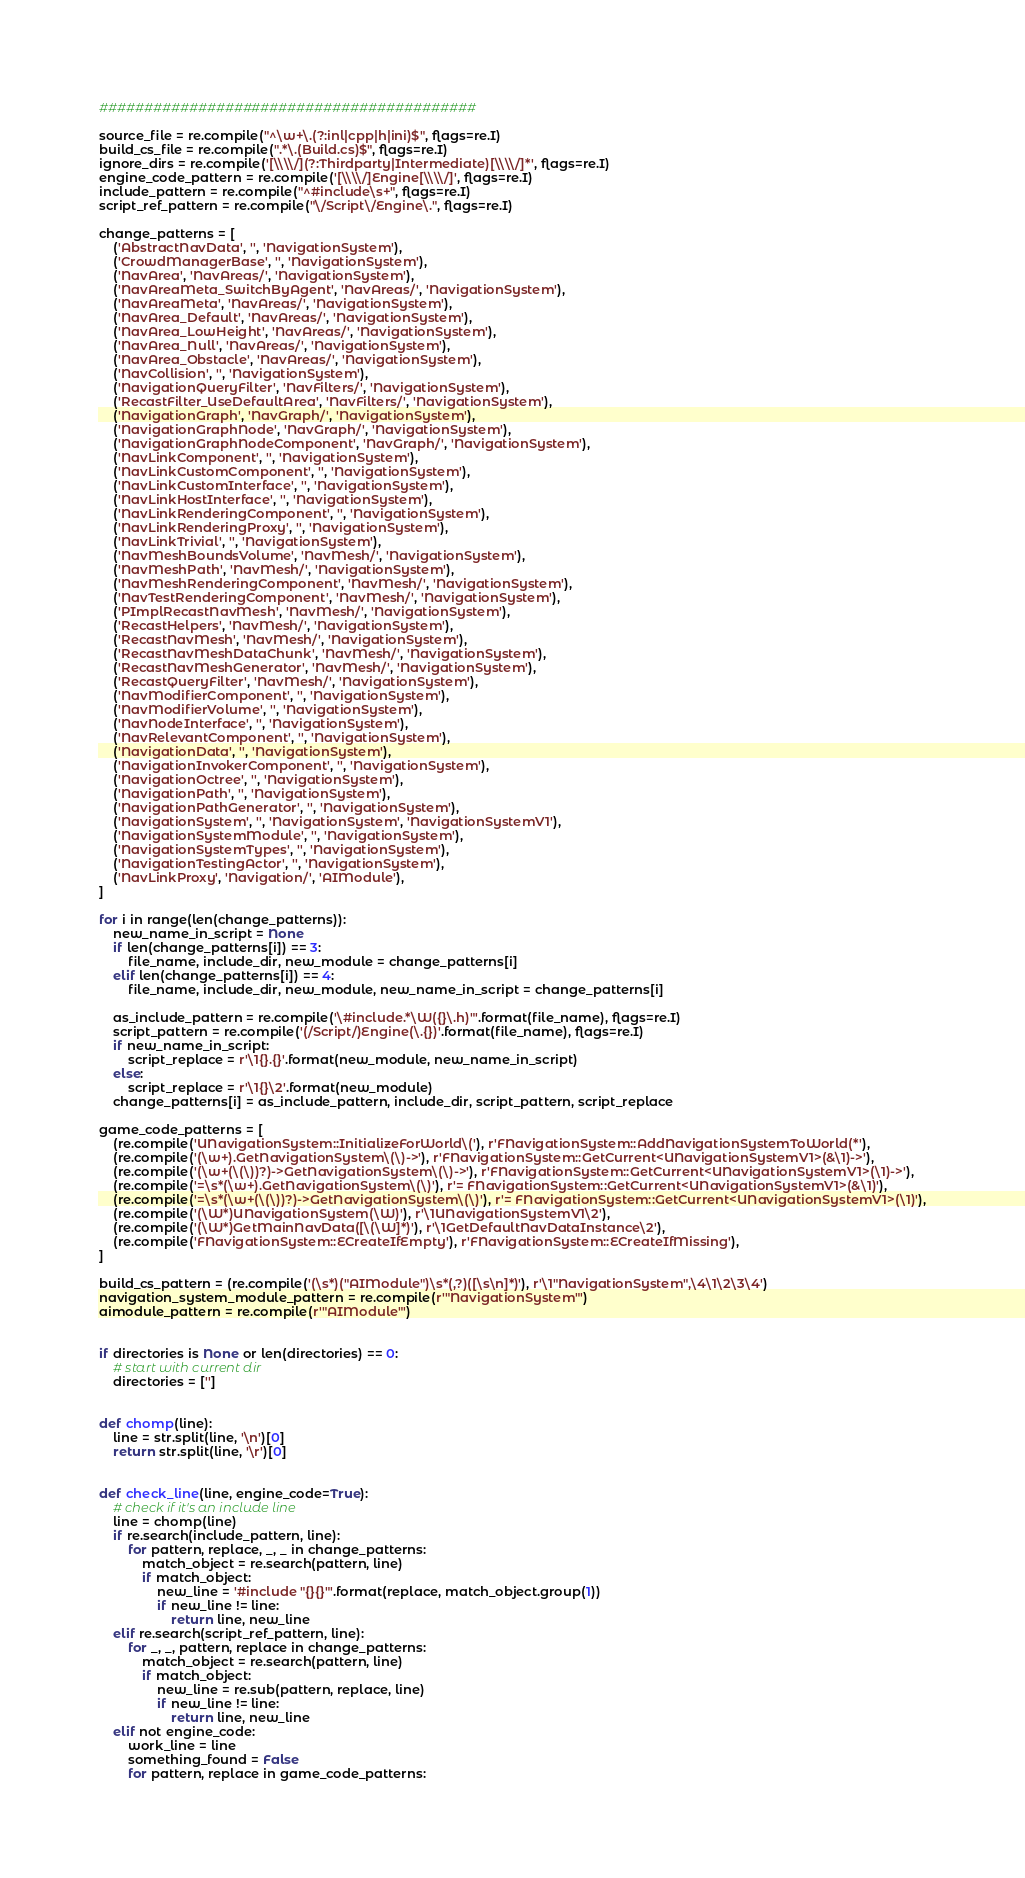Convert code to text. <code><loc_0><loc_0><loc_500><loc_500><_Python_>##########################################

source_file = re.compile("^\w+\.(?:inl|cpp|h|ini)$", flags=re.I)
build_cs_file = re.compile(".*\.(Build.cs)$", flags=re.I)
ignore_dirs = re.compile('[\\\\/](?:Thirdparty|Intermediate)[\\\\/]*', flags=re.I)
engine_code_pattern = re.compile('[\\\\/]Engine[\\\\/]', flags=re.I)
include_pattern = re.compile("^#include\s+", flags=re.I)
script_ref_pattern = re.compile("\/Script\/Engine\.", flags=re.I)

change_patterns = [
    ('AbstractNavData', '', 'NavigationSystem'),
    ('CrowdManagerBase', '', 'NavigationSystem'),
    ('NavArea', 'NavAreas/', 'NavigationSystem'),
    ('NavAreaMeta_SwitchByAgent', 'NavAreas/', 'NavigationSystem'),
    ('NavAreaMeta', 'NavAreas/', 'NavigationSystem'),
    ('NavArea_Default', 'NavAreas/', 'NavigationSystem'),
    ('NavArea_LowHeight', 'NavAreas/', 'NavigationSystem'),
    ('NavArea_Null', 'NavAreas/', 'NavigationSystem'),
    ('NavArea_Obstacle', 'NavAreas/', 'NavigationSystem'),
    ('NavCollision', '', 'NavigationSystem'),
    ('NavigationQueryFilter', 'NavFilters/', 'NavigationSystem'),
    ('RecastFilter_UseDefaultArea', 'NavFilters/', 'NavigationSystem'),
    ('NavigationGraph', 'NavGraph/', 'NavigationSystem'),
    ('NavigationGraphNode', 'NavGraph/', 'NavigationSystem'),
    ('NavigationGraphNodeComponent', 'NavGraph/', 'NavigationSystem'),
    ('NavLinkComponent', '', 'NavigationSystem'),
    ('NavLinkCustomComponent', '', 'NavigationSystem'),
    ('NavLinkCustomInterface', '', 'NavigationSystem'),
    ('NavLinkHostInterface', '', 'NavigationSystem'),
    ('NavLinkRenderingComponent', '', 'NavigationSystem'),
    ('NavLinkRenderingProxy', '', 'NavigationSystem'),
    ('NavLinkTrivial', '', 'NavigationSystem'),
    ('NavMeshBoundsVolume', 'NavMesh/', 'NavigationSystem'),
    ('NavMeshPath', 'NavMesh/', 'NavigationSystem'),
    ('NavMeshRenderingComponent', 'NavMesh/', 'NavigationSystem'),
    ('NavTestRenderingComponent', 'NavMesh/', 'NavigationSystem'),
    ('PImplRecastNavMesh', 'NavMesh/', 'NavigationSystem'),
    ('RecastHelpers', 'NavMesh/', 'NavigationSystem'),
    ('RecastNavMesh', 'NavMesh/', 'NavigationSystem'),
    ('RecastNavMeshDataChunk', 'NavMesh/', 'NavigationSystem'),
    ('RecastNavMeshGenerator', 'NavMesh/', 'NavigationSystem'),
    ('RecastQueryFilter', 'NavMesh/', 'NavigationSystem'),
    ('NavModifierComponent', '', 'NavigationSystem'),
    ('NavModifierVolume', '', 'NavigationSystem'),
    ('NavNodeInterface', '', 'NavigationSystem'),
    ('NavRelevantComponent', '', 'NavigationSystem'),
    ('NavigationData', '', 'NavigationSystem'),
    ('NavigationInvokerComponent', '', 'NavigationSystem'),
    ('NavigationOctree', '', 'NavigationSystem'),
    ('NavigationPath', '', 'NavigationSystem'),
    ('NavigationPathGenerator', '', 'NavigationSystem'),
    ('NavigationSystem', '', 'NavigationSystem', 'NavigationSystemV1'),
    ('NavigationSystemModule', '', 'NavigationSystem'),
    ('NavigationSystemTypes', '', 'NavigationSystem'),
    ('NavigationTestingActor', '', 'NavigationSystem'),
    ('NavLinkProxy', 'Navigation/', 'AIModule'),
]

for i in range(len(change_patterns)):
    new_name_in_script = None
    if len(change_patterns[i]) == 3:
        file_name, include_dir, new_module = change_patterns[i]
    elif len(change_patterns[i]) == 4:
        file_name, include_dir, new_module, new_name_in_script = change_patterns[i]

    as_include_pattern = re.compile('\#include.*\W({}\.h)"'.format(file_name), flags=re.I)
    script_pattern = re.compile('(/Script/)Engine(\.{})'.format(file_name), flags=re.I)
    if new_name_in_script:
        script_replace = r'\1{}.{}'.format(new_module, new_name_in_script)
    else:
        script_replace = r'\1{}\2'.format(new_module)
    change_patterns[i] = as_include_pattern, include_dir, script_pattern, script_replace

game_code_patterns = [
    (re.compile('UNavigationSystem::InitializeForWorld\('), r'FNavigationSystem::AddNavigationSystemToWorld(*'),
    (re.compile('(\w+).GetNavigationSystem\(\)->'), r'FNavigationSystem::GetCurrent<UNavigationSystemV1>(&\1)->'),
    (re.compile('(\w+(\(\))?)->GetNavigationSystem\(\)->'), r'FNavigationSystem::GetCurrent<UNavigationSystemV1>(\1)->'),
    (re.compile('=\s*(\w+).GetNavigationSystem\(\)'), r'= FNavigationSystem::GetCurrent<UNavigationSystemV1>(&\1)'),
    (re.compile('=\s*(\w+(\(\))?)->GetNavigationSystem\(\)'), r'= FNavigationSystem::GetCurrent<UNavigationSystemV1>(\1)'),
    (re.compile('(\W*)UNavigationSystem(\W)'), r'\1UNavigationSystemV1\2'),
    (re.compile('(\W*)GetMainNavData([\(\W]*)'), r'\1GetDefaultNavDataInstance\2'),
    (re.compile('FNavigationSystem::ECreateIfEmpty'), r'FNavigationSystem::ECreateIfMissing'),
]

build_cs_pattern = (re.compile('(\s*)("AIModule")\s*(,?)([\s\n]*)'), r'\1"NavigationSystem",\4\1\2\3\4')
navigation_system_module_pattern = re.compile(r'"NavigationSystem"')
aimodule_pattern = re.compile(r'"AIModule"')


if directories is None or len(directories) == 0:
    # start with current dir
    directories = ['']


def chomp(line):
    line = str.split(line, '\n')[0]
    return str.split(line, '\r')[0]


def check_line(line, engine_code=True):
    # check if it's an include line
    line = chomp(line)
    if re.search(include_pattern, line):
        for pattern, replace, _, _ in change_patterns:
            match_object = re.search(pattern, line)
            if match_object:
                new_line = '#include "{}{}"'.format(replace, match_object.group(1))
                if new_line != line:
                    return line, new_line
    elif re.search(script_ref_pattern, line):
        for _, _, pattern, replace in change_patterns:
            match_object = re.search(pattern, line)
            if match_object:
                new_line = re.sub(pattern, replace, line)
                if new_line != line:
                    return line, new_line
    elif not engine_code:
        work_line = line
        something_found = False
        for pattern, replace in game_code_patterns:</code> 